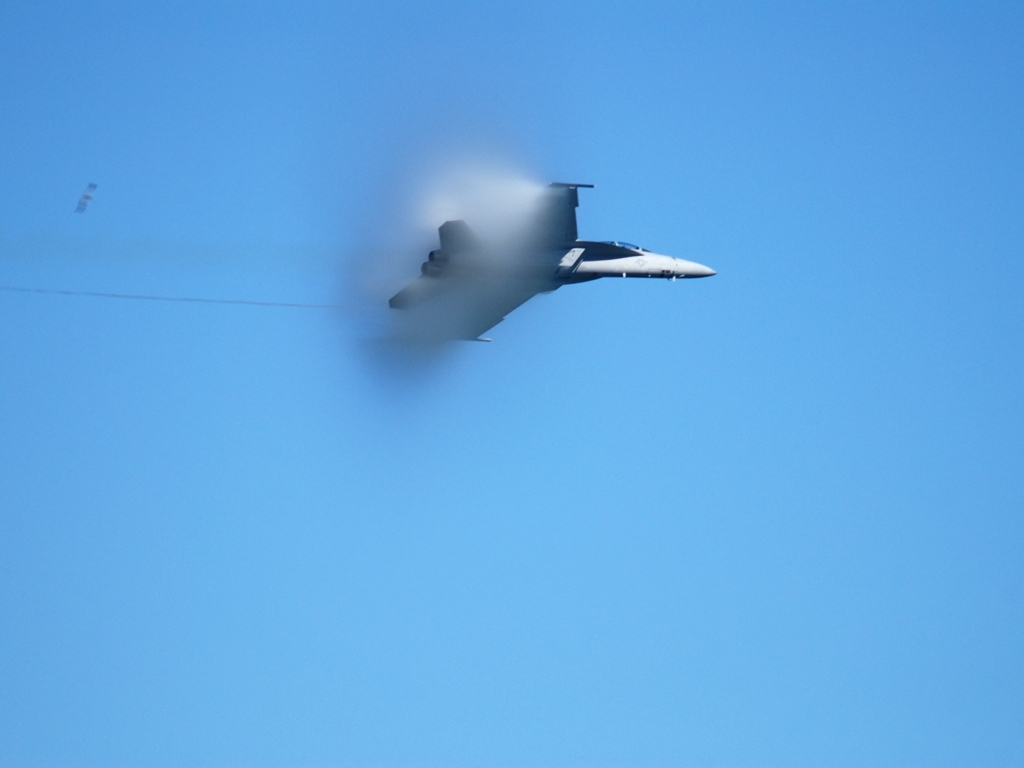What can you tell about the speed of the aircraft? While it's not possible to determine the exact speed without additional information, the presence of the vapor cone around the aircraft suggests it is flying at near transonic speeds, which is near the speed of sound. This indicates that the aircraft is likely a high-performance military jet designed to operate at high velocities. 